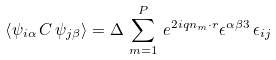<formula> <loc_0><loc_0><loc_500><loc_500>\left < \psi _ { i \alpha } \, C \, \psi _ { j \beta } \right > = \Delta \, \sum _ { m = 1 } ^ { P } \, e ^ { 2 i q { n _ { m } } \cdot { r } } \epsilon ^ { \alpha \beta 3 } \, \epsilon _ { i j }</formula> 